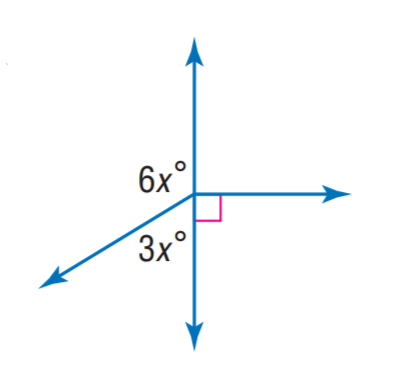Question: Find x.
Choices:
A. 10
B. 20
C. 30
D. 40
Answer with the letter. Answer: B 